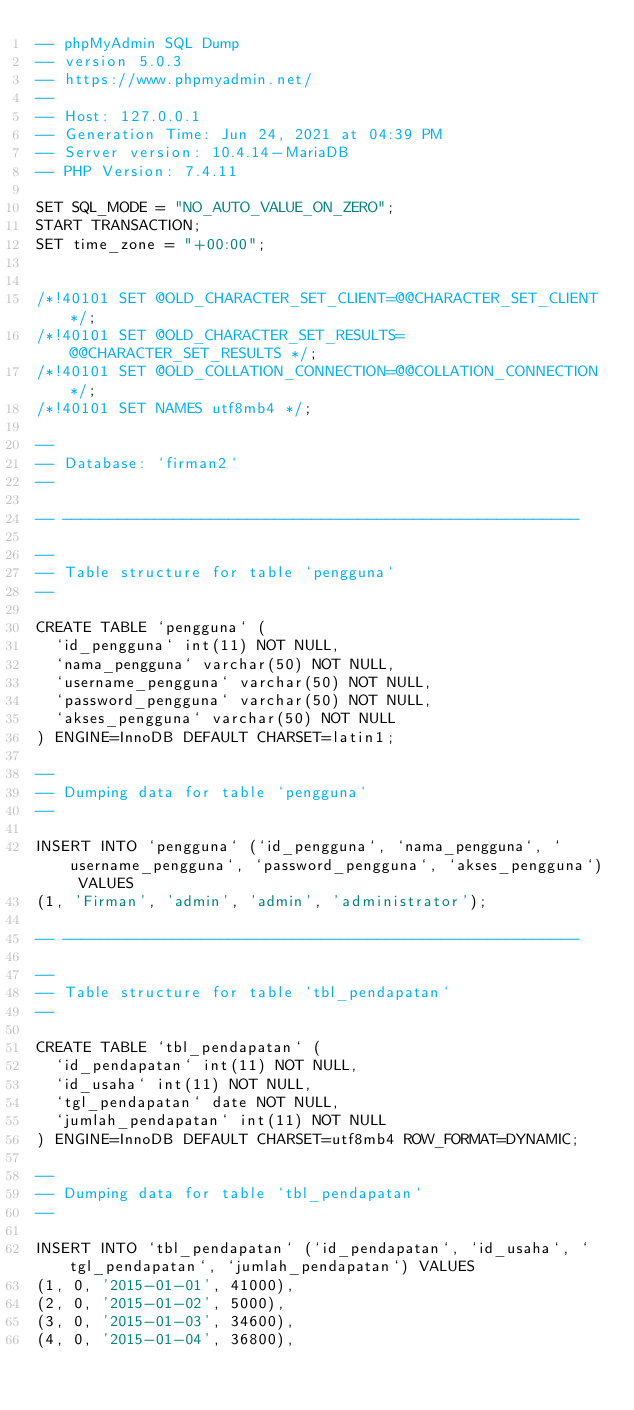<code> <loc_0><loc_0><loc_500><loc_500><_SQL_>-- phpMyAdmin SQL Dump
-- version 5.0.3
-- https://www.phpmyadmin.net/
--
-- Host: 127.0.0.1
-- Generation Time: Jun 24, 2021 at 04:39 PM
-- Server version: 10.4.14-MariaDB
-- PHP Version: 7.4.11

SET SQL_MODE = "NO_AUTO_VALUE_ON_ZERO";
START TRANSACTION;
SET time_zone = "+00:00";


/*!40101 SET @OLD_CHARACTER_SET_CLIENT=@@CHARACTER_SET_CLIENT */;
/*!40101 SET @OLD_CHARACTER_SET_RESULTS=@@CHARACTER_SET_RESULTS */;
/*!40101 SET @OLD_COLLATION_CONNECTION=@@COLLATION_CONNECTION */;
/*!40101 SET NAMES utf8mb4 */;

--
-- Database: `firman2`
--

-- --------------------------------------------------------

--
-- Table structure for table `pengguna`
--

CREATE TABLE `pengguna` (
  `id_pengguna` int(11) NOT NULL,
  `nama_pengguna` varchar(50) NOT NULL,
  `username_pengguna` varchar(50) NOT NULL,
  `password_pengguna` varchar(50) NOT NULL,
  `akses_pengguna` varchar(50) NOT NULL
) ENGINE=InnoDB DEFAULT CHARSET=latin1;

--
-- Dumping data for table `pengguna`
--

INSERT INTO `pengguna` (`id_pengguna`, `nama_pengguna`, `username_pengguna`, `password_pengguna`, `akses_pengguna`) VALUES
(1, 'Firman', 'admin', 'admin', 'administrator');

-- --------------------------------------------------------

--
-- Table structure for table `tbl_pendapatan`
--

CREATE TABLE `tbl_pendapatan` (
  `id_pendapatan` int(11) NOT NULL,
  `id_usaha` int(11) NOT NULL,
  `tgl_pendapatan` date NOT NULL,
  `jumlah_pendapatan` int(11) NOT NULL
) ENGINE=InnoDB DEFAULT CHARSET=utf8mb4 ROW_FORMAT=DYNAMIC;

--
-- Dumping data for table `tbl_pendapatan`
--

INSERT INTO `tbl_pendapatan` (`id_pendapatan`, `id_usaha`, `tgl_pendapatan`, `jumlah_pendapatan`) VALUES
(1, 0, '2015-01-01', 41000),
(2, 0, '2015-01-02', 5000),
(3, 0, '2015-01-03', 34600),
(4, 0, '2015-01-04', 36800),</code> 